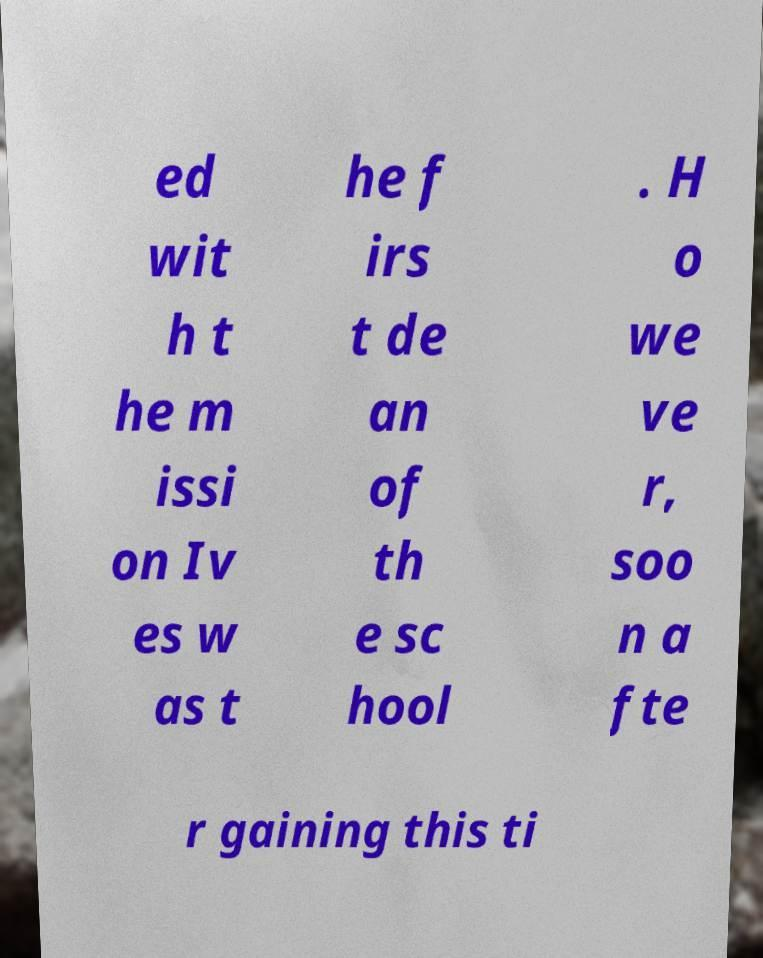Could you assist in decoding the text presented in this image and type it out clearly? ed wit h t he m issi on Iv es w as t he f irs t de an of th e sc hool . H o we ve r, soo n a fte r gaining this ti 